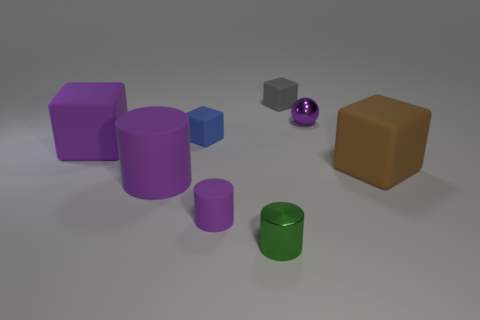Subtract all green cubes. Subtract all cyan cylinders. How many cubes are left? 4 Add 1 large purple rubber cylinders. How many objects exist? 9 Subtract all balls. How many objects are left? 7 Subtract 0 brown cylinders. How many objects are left? 8 Subtract all brown matte objects. Subtract all green things. How many objects are left? 6 Add 6 tiny blue rubber blocks. How many tiny blue rubber blocks are left? 7 Add 2 purple rubber blocks. How many purple rubber blocks exist? 3 